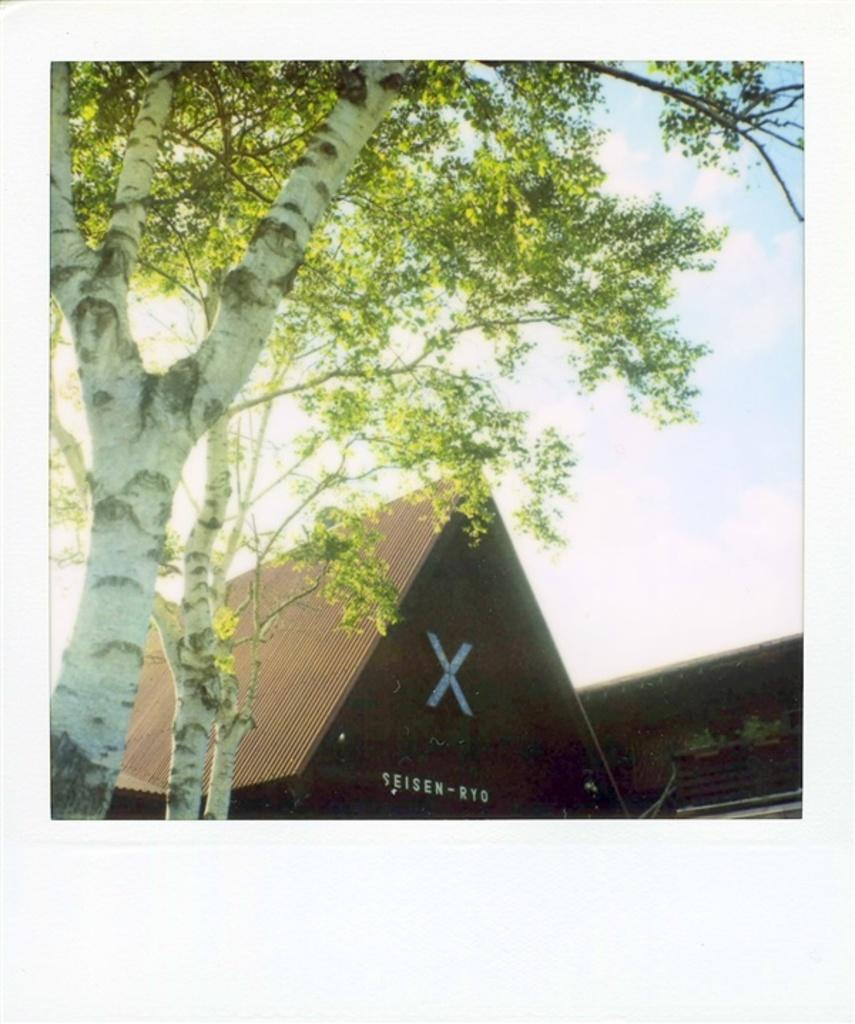What type of natural element is present in the image? There is a tree in the image. What type of structure is present in the image? There is a house in the image. What is the condition of the sky in the image? The sky is cloudy in the image. What type of drain is visible in the image? There is no drain present in the image. What idea does the tree represent in the image? The image does not convey any specific ideas or symbolism related to the tree. 